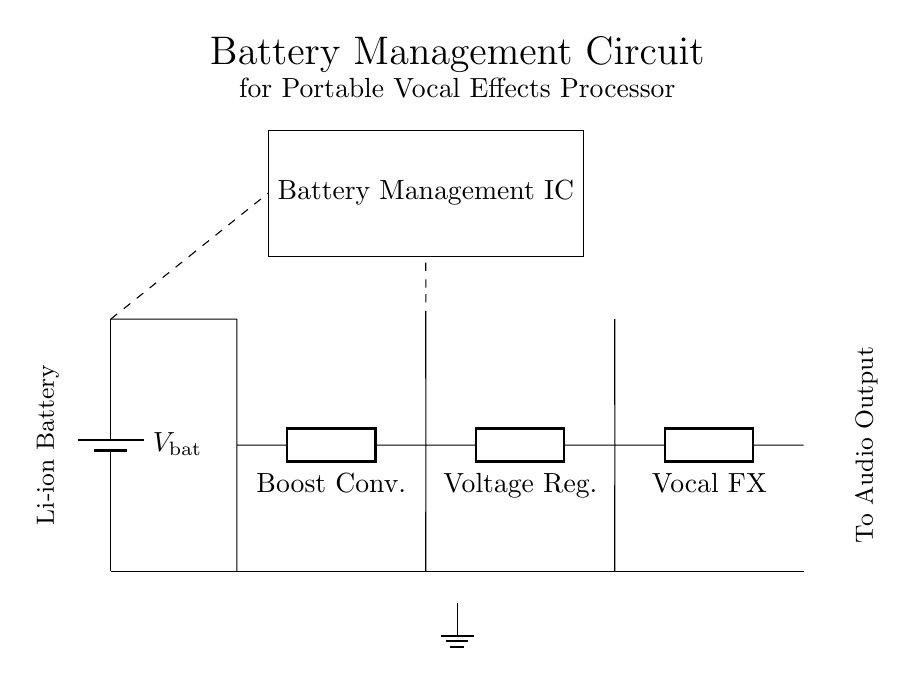What is the type of battery used in this circuit? The circuit specifies the use of a lithium-ion battery, indicated by the label next to the battery symbol.
Answer: Lithium-ion What component is responsible for increasing voltage? The boost converter, which is indicated by the label "Boost Conv.," is designed to step up the voltage from the battery to a higher level for the rest of the circuit.
Answer: Boost converter What is the purpose of the battery management IC? The battery management IC is crucial for monitoring and protecting the battery during operation, ensuring safe charging and discharging, and extending battery life.
Answer: Battery management How many main components are in this circuit? A quick count shows five main components: a battery, a boost converter, a voltage regulator, a vocal effects processor, and a battery management IC.
Answer: Five What does the voltage regulator do? The voltage regulator ensures a stable output voltage for the vocal effects processor, maintaining optimal performance regardless of variations in input voltage from the boost converter.
Answer: Stabilizes output voltage What is the output of this circuit connected to? The circuit output is connected to the audio output labeled at the far end, which indicates that it sends processed audio signals to an output device.
Answer: Audio output 